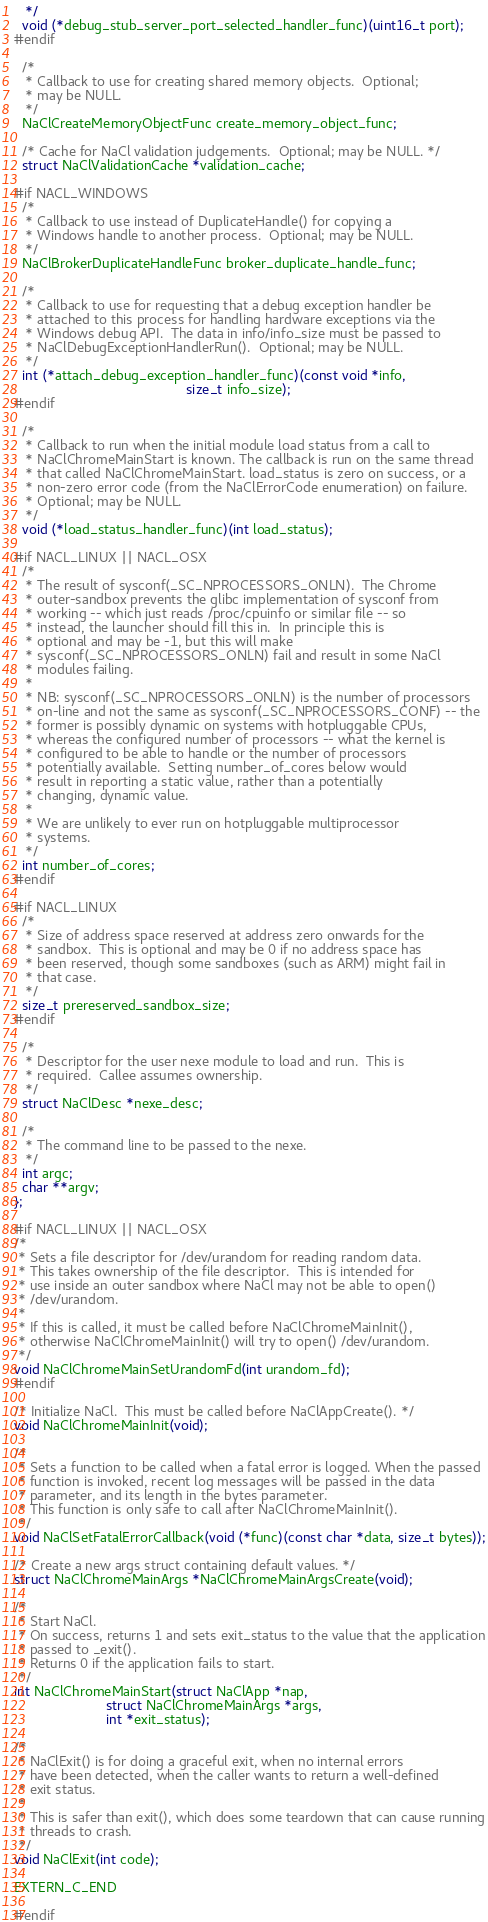<code> <loc_0><loc_0><loc_500><loc_500><_C_>   */
  void (*debug_stub_server_port_selected_handler_func)(uint16_t port);
#endif

  /*
   * Callback to use for creating shared memory objects.  Optional;
   * may be NULL.
   */
  NaClCreateMemoryObjectFunc create_memory_object_func;

  /* Cache for NaCl validation judgements.  Optional; may be NULL. */
  struct NaClValidationCache *validation_cache;

#if NACL_WINDOWS
  /*
   * Callback to use instead of DuplicateHandle() for copying a
   * Windows handle to another process.  Optional; may be NULL.
   */
  NaClBrokerDuplicateHandleFunc broker_duplicate_handle_func;

  /*
   * Callback to use for requesting that a debug exception handler be
   * attached to this process for handling hardware exceptions via the
   * Windows debug API.  The data in info/info_size must be passed to
   * NaClDebugExceptionHandlerRun().  Optional; may be NULL.
   */
  int (*attach_debug_exception_handler_func)(const void *info,
                                             size_t info_size);
#endif

  /*
   * Callback to run when the initial module load status from a call to
   * NaClChromeMainStart is known. The callback is run on the same thread
   * that called NaClChromeMainStart. load_status is zero on success, or a
   * non-zero error code (from the NaClErrorCode enumeration) on failure.
   * Optional; may be NULL.
   */
  void (*load_status_handler_func)(int load_status);

#if NACL_LINUX || NACL_OSX
  /*
   * The result of sysconf(_SC_NPROCESSORS_ONLN).  The Chrome
   * outer-sandbox prevents the glibc implementation of sysconf from
   * working -- which just reads /proc/cpuinfo or similar file -- so
   * instead, the launcher should fill this in.  In principle this is
   * optional and may be -1, but this will make
   * sysconf(_SC_NPROCESSORS_ONLN) fail and result in some NaCl
   * modules failing.
   *
   * NB: sysconf(_SC_NPROCESSORS_ONLN) is the number of processors
   * on-line and not the same as sysconf(_SC_NPROCESSORS_CONF) -- the
   * former is possibly dynamic on systems with hotpluggable CPUs,
   * whereas the configured number of processors -- what the kernel is
   * configured to be able to handle or the number of processors
   * potentially available.  Setting number_of_cores below would
   * result in reporting a static value, rather than a potentially
   * changing, dynamic value.
   *
   * We are unlikely to ever run on hotpluggable multiprocessor
   * systems.
   */
  int number_of_cores;
#endif

#if NACL_LINUX
  /*
   * Size of address space reserved at address zero onwards for the
   * sandbox.  This is optional and may be 0 if no address space has
   * been reserved, though some sandboxes (such as ARM) might fail in
   * that case.
   */
  size_t prereserved_sandbox_size;
#endif

  /*
   * Descriptor for the user nexe module to load and run.  This is
   * required.  Callee assumes ownership.
   */
  struct NaClDesc *nexe_desc;

  /*
   * The command line to be passed to the nexe.
   */
  int argc;
  char **argv;
};

#if NACL_LINUX || NACL_OSX
/*
 * Sets a file descriptor for /dev/urandom for reading random data.
 * This takes ownership of the file descriptor.  This is intended for
 * use inside an outer sandbox where NaCl may not be able to open()
 * /dev/urandom.
 *
 * If this is called, it must be called before NaClChromeMainInit(),
 * otherwise NaClChromeMainInit() will try to open() /dev/urandom.
 */
void NaClChromeMainSetUrandomFd(int urandom_fd);
#endif

/* Initialize NaCl.  This must be called before NaClAppCreate(). */
void NaClChromeMainInit(void);

/*
 * Sets a function to be called when a fatal error is logged. When the passed
 * function is invoked, recent log messages will be passed in the data
 * parameter, and its length in the bytes parameter.
 * This function is only safe to call after NaClChromeMainInit().
 */
void NaClSetFatalErrorCallback(void (*func)(const char *data, size_t bytes));

/* Create a new args struct containing default values. */
struct NaClChromeMainArgs *NaClChromeMainArgsCreate(void);

/*
 * Start NaCl.
 * On success, returns 1 and sets exit_status to the value that the application
 * passed to _exit().
 * Returns 0 if the application fails to start.
 */
int NaClChromeMainStart(struct NaClApp *nap,
                        struct NaClChromeMainArgs *args,
                        int *exit_status);

/*
 * NaClExit() is for doing a graceful exit, when no internal errors
 * have been detected, when the caller wants to return a well-defined
 * exit status.
 *
 * This is safer than exit(), which does some teardown that can cause running
 * threads to crash.
 */
void NaClExit(int code);

EXTERN_C_END

#endif
</code> 